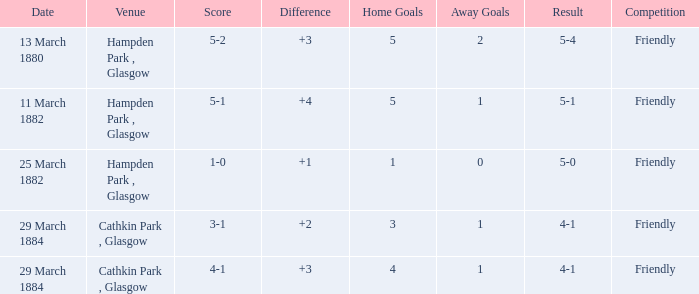Which item resulted in a score of 4-1? 3-1, 4-1. 